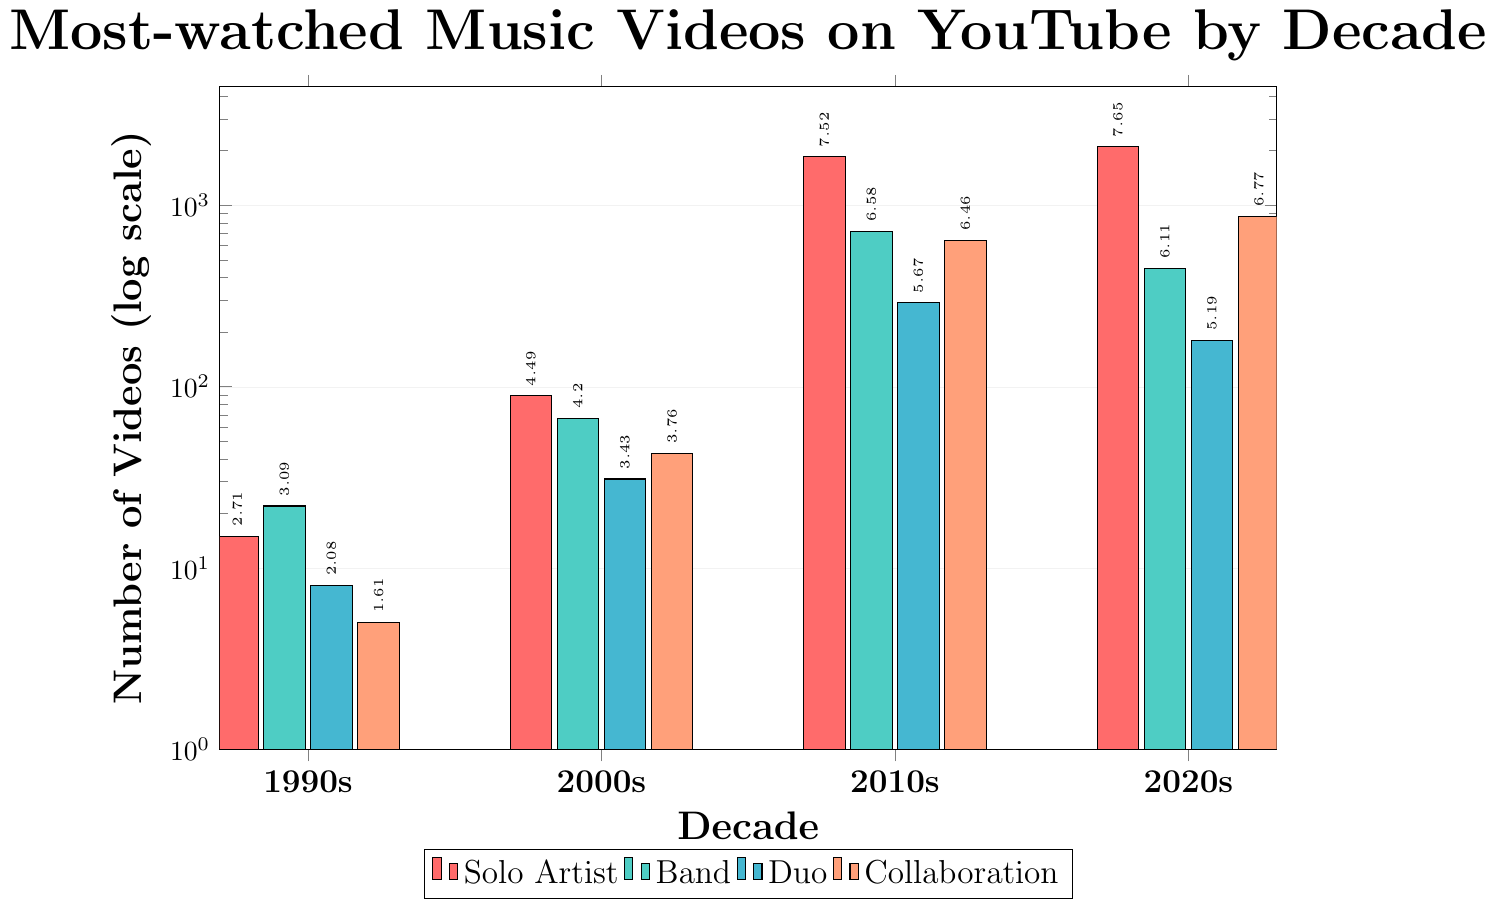Which decade has the highest number of most-watched music videos by solo artists? The bar chart shows four decades: 1990s, 2000s, 2010s, and 2020s. By comparing the heights of the bars for solo artists across these decades, the 2020s has the tallest bar, indicating the highest number of most-watched music videos by solo artists.
Answer: 2020s How many most-watched music videos in total were there in the 1990s? To find the total number of videos, sum the values for solo artist, band, duo, and collaboration in the 1990s: 15 (solo) + 22 (band) + 8 (duo) + 5 (collaboration) = 50.
Answer: 50 Which artist type saw the most significant growth from the 2000s to the 2010s? To determine the most significant growth, calculate the difference in the number of most-watched videos for each artist type between the 2000s and the 2010s: Solo Artist (1850 - 89 = 1761), Band (720 - 67 = 653), Duo (290 - 31 = 259), Collaboration (640 - 43 = 597). The greatest increase is for Solo Artists with 1761.
Answer: Solo Artist Compare the number of most-watched music videos by bands in the 2010s and 2020s. Which decade has fewer, and by how much? The number of most-watched music videos by bands in the 2010s is 720 and in the 2020s is 450. The 2020s have fewer by 720 - 450 = 270.
Answer: 2020s, 270 fewer What is the proportion of collaboration videos to solo artist videos in the 2020s? In the 2020s, the number of collaboration videos is 870 and solo artist videos is 2100. The proportion of collaboration to solo artist videos is 870 / 2100 ≈ 0.414.
Answer: 0.414 In which decade did duo artist videos increase the least compared to the previous decade? Calculate the increase in duo artist videos from one decade to the next: 1990s to 2000s (31 - 8 = 23), 2000s to 2010s (290 - 31 = 259), 2010s to 2020s (180 - 290 = -110). The least increase (and in this case, a decrease) occurred from 2010s to 2020s.
Answer: 2010s to 2020s By what factor did the number of solo artist videos increase from the 1990s to the 2020s? The number of solo artist videos in the 1990s is 15 and in the 2020s is 2100. The increase factor is 2100 / 15 = 140.
Answer: 140 Which two decades had the closest number of most-watched music videos by collaborations? Compare the collaboration videos across decades: 1990s (5), 2000s (43), 2010s (640), and 2020s (870). The closest numbers are between 2000s (43) and 1990s (5) with a difference of 43 - 5 = 38.
Answer: 1990s and 2000s 